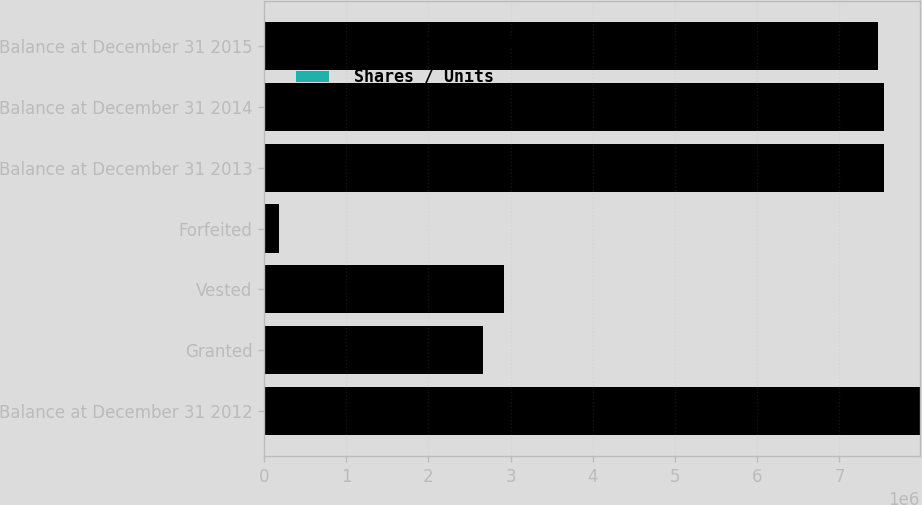Convert chart. <chart><loc_0><loc_0><loc_500><loc_500><stacked_bar_chart><ecel><fcel>Balance at December 31 2012<fcel>Granted<fcel>Vested<fcel>Forfeited<fcel>Balance at December 31 2013<fcel>Balance at December 31 2014<fcel>Balance at December 31 2015<nl><fcel>Weighted Average Market Value Per Share<fcel>7.97349e+06<fcel>2.66941e+06<fcel>2.92348e+06<fcel>177905<fcel>7.54151e+06<fcel>7.5421e+06<fcel>7.46706e+06<nl><fcel>Shares / Units<fcel>17.65<fcel>22.94<fcel>14.48<fcel>18.15<fcel>20.76<fcel>22.53<fcel>29.08<nl></chart> 